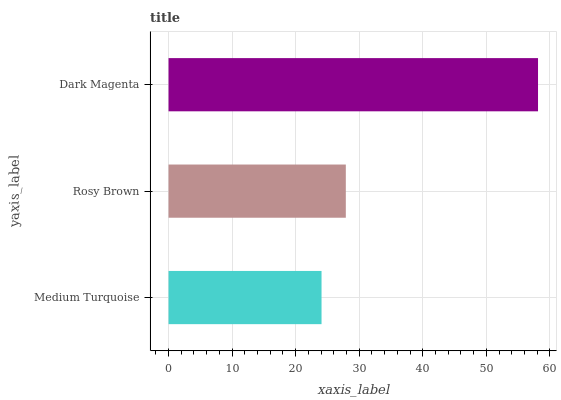Is Medium Turquoise the minimum?
Answer yes or no. Yes. Is Dark Magenta the maximum?
Answer yes or no. Yes. Is Rosy Brown the minimum?
Answer yes or no. No. Is Rosy Brown the maximum?
Answer yes or no. No. Is Rosy Brown greater than Medium Turquoise?
Answer yes or no. Yes. Is Medium Turquoise less than Rosy Brown?
Answer yes or no. Yes. Is Medium Turquoise greater than Rosy Brown?
Answer yes or no. No. Is Rosy Brown less than Medium Turquoise?
Answer yes or no. No. Is Rosy Brown the high median?
Answer yes or no. Yes. Is Rosy Brown the low median?
Answer yes or no. Yes. Is Medium Turquoise the high median?
Answer yes or no. No. Is Medium Turquoise the low median?
Answer yes or no. No. 